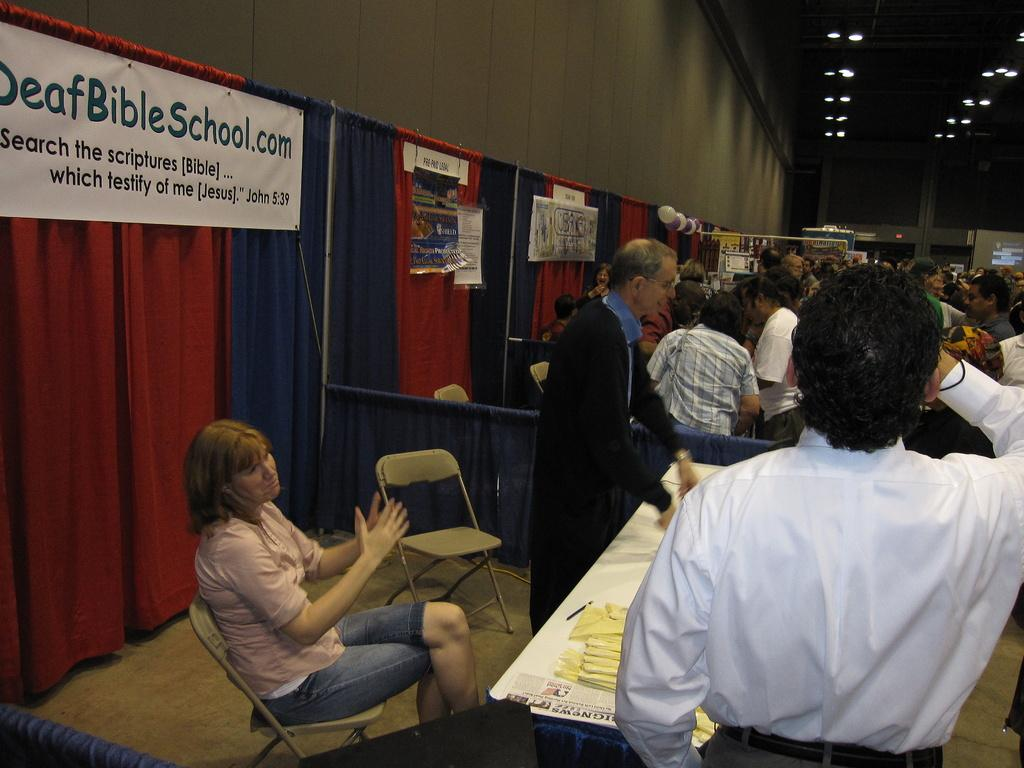How many people are in the image? There are several people in the image. What are the people doing in the image? Each person is in their respective stall. What can be seen in the background of the image? The background is made of curtains. Can you describe the curtains in the image? The curtains have different designs. What type of mask is the person in the middle wearing in the image? There is no mask visible on any person in the image. What color is the shirt of the person on the right in the image? We cannot determine the color of any person's shirt in the image, as the focus is on the stalls and curtains. 